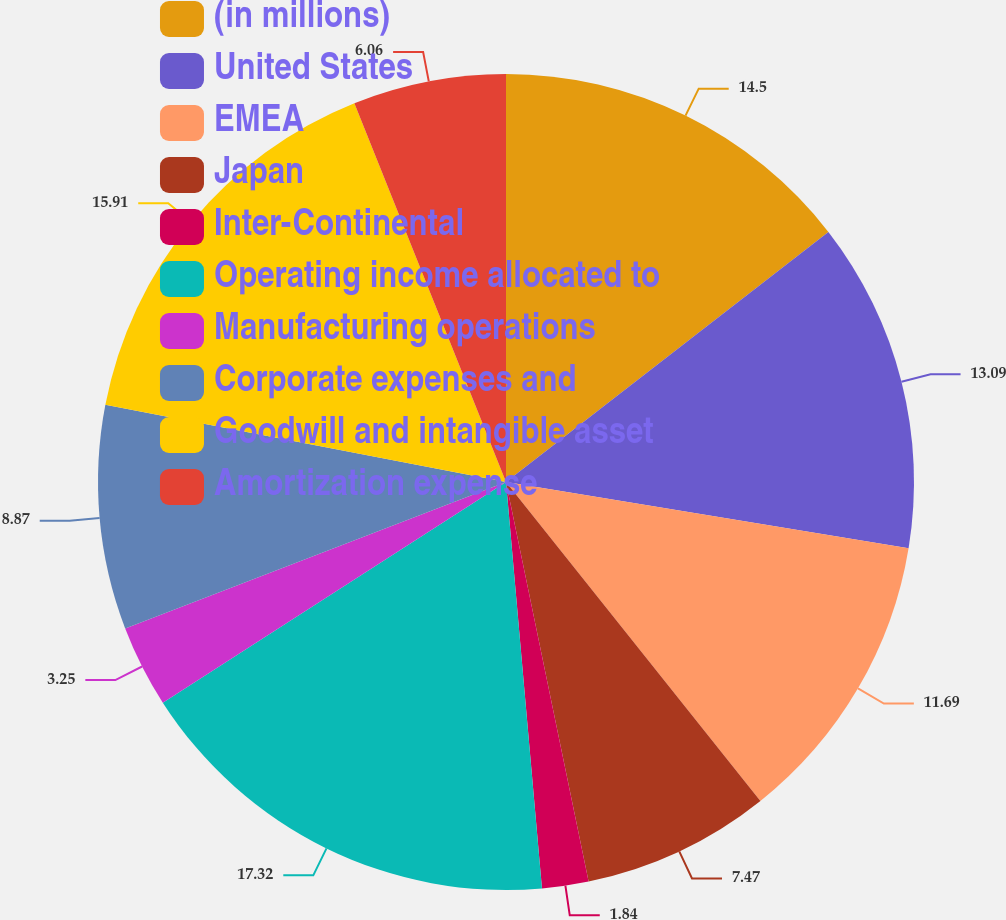Convert chart to OTSL. <chart><loc_0><loc_0><loc_500><loc_500><pie_chart><fcel>(in millions)<fcel>United States<fcel>EMEA<fcel>Japan<fcel>Inter-Continental<fcel>Operating income allocated to<fcel>Manufacturing operations<fcel>Corporate expenses and<fcel>Goodwill and intangible asset<fcel>Amortization expense<nl><fcel>14.5%<fcel>13.09%<fcel>11.69%<fcel>7.47%<fcel>1.84%<fcel>17.31%<fcel>3.25%<fcel>8.87%<fcel>15.91%<fcel>6.06%<nl></chart> 